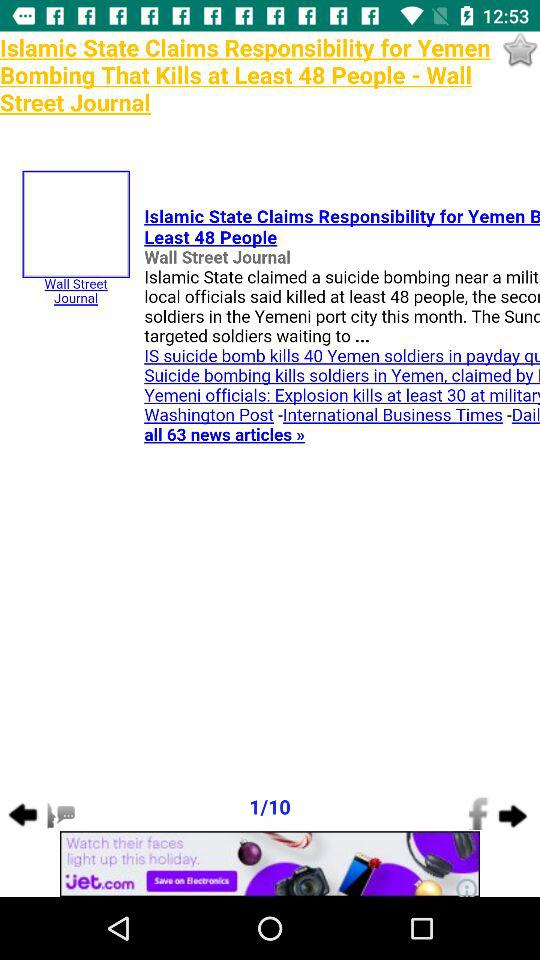How many pages in total are there? There are 10 pages in total. 